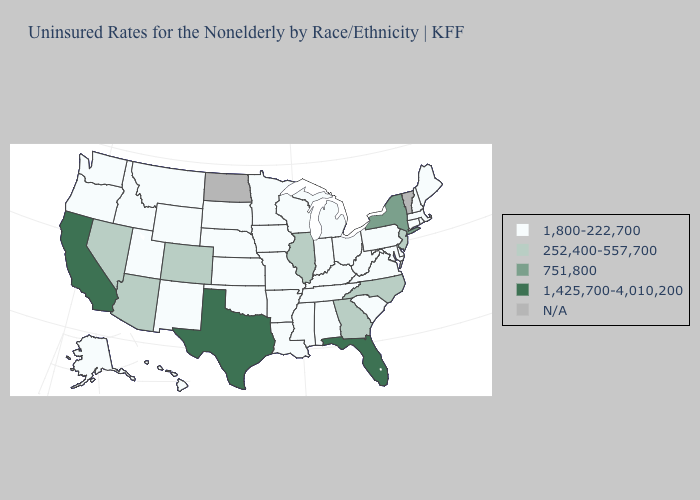Is the legend a continuous bar?
Concise answer only. No. Name the states that have a value in the range 1,800-222,700?
Answer briefly. Alabama, Alaska, Arkansas, Connecticut, Delaware, Hawaii, Idaho, Indiana, Iowa, Kansas, Kentucky, Louisiana, Maine, Maryland, Massachusetts, Michigan, Minnesota, Mississippi, Missouri, Montana, Nebraska, New Hampshire, New Mexico, Ohio, Oklahoma, Oregon, Pennsylvania, Rhode Island, South Carolina, South Dakota, Tennessee, Utah, Virginia, Washington, West Virginia, Wisconsin, Wyoming. Name the states that have a value in the range 1,425,700-4,010,200?
Keep it brief. California, Florida, Texas. What is the lowest value in states that border Illinois?
Be succinct. 1,800-222,700. What is the value of Rhode Island?
Be succinct. 1,800-222,700. Which states have the lowest value in the South?
Answer briefly. Alabama, Arkansas, Delaware, Kentucky, Louisiana, Maryland, Mississippi, Oklahoma, South Carolina, Tennessee, Virginia, West Virginia. Which states have the lowest value in the USA?
Write a very short answer. Alabama, Alaska, Arkansas, Connecticut, Delaware, Hawaii, Idaho, Indiana, Iowa, Kansas, Kentucky, Louisiana, Maine, Maryland, Massachusetts, Michigan, Minnesota, Mississippi, Missouri, Montana, Nebraska, New Hampshire, New Mexico, Ohio, Oklahoma, Oregon, Pennsylvania, Rhode Island, South Carolina, South Dakota, Tennessee, Utah, Virginia, Washington, West Virginia, Wisconsin, Wyoming. Does Missouri have the lowest value in the MidWest?
Answer briefly. Yes. Name the states that have a value in the range 1,800-222,700?
Concise answer only. Alabama, Alaska, Arkansas, Connecticut, Delaware, Hawaii, Idaho, Indiana, Iowa, Kansas, Kentucky, Louisiana, Maine, Maryland, Massachusetts, Michigan, Minnesota, Mississippi, Missouri, Montana, Nebraska, New Hampshire, New Mexico, Ohio, Oklahoma, Oregon, Pennsylvania, Rhode Island, South Carolina, South Dakota, Tennessee, Utah, Virginia, Washington, West Virginia, Wisconsin, Wyoming. Among the states that border Kansas , does Oklahoma have the lowest value?
Be succinct. Yes. What is the value of Hawaii?
Concise answer only. 1,800-222,700. Is the legend a continuous bar?
Answer briefly. No. What is the lowest value in the USA?
Write a very short answer. 1,800-222,700. What is the highest value in the Northeast ?
Answer briefly. 751,800. 